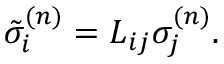Convert formula to latex. <formula><loc_0><loc_0><loc_500><loc_500>\tilde { \sigma } _ { i } ^ { ( n ) } = L _ { i j } \sigma _ { j } ^ { ( n ) } .</formula> 